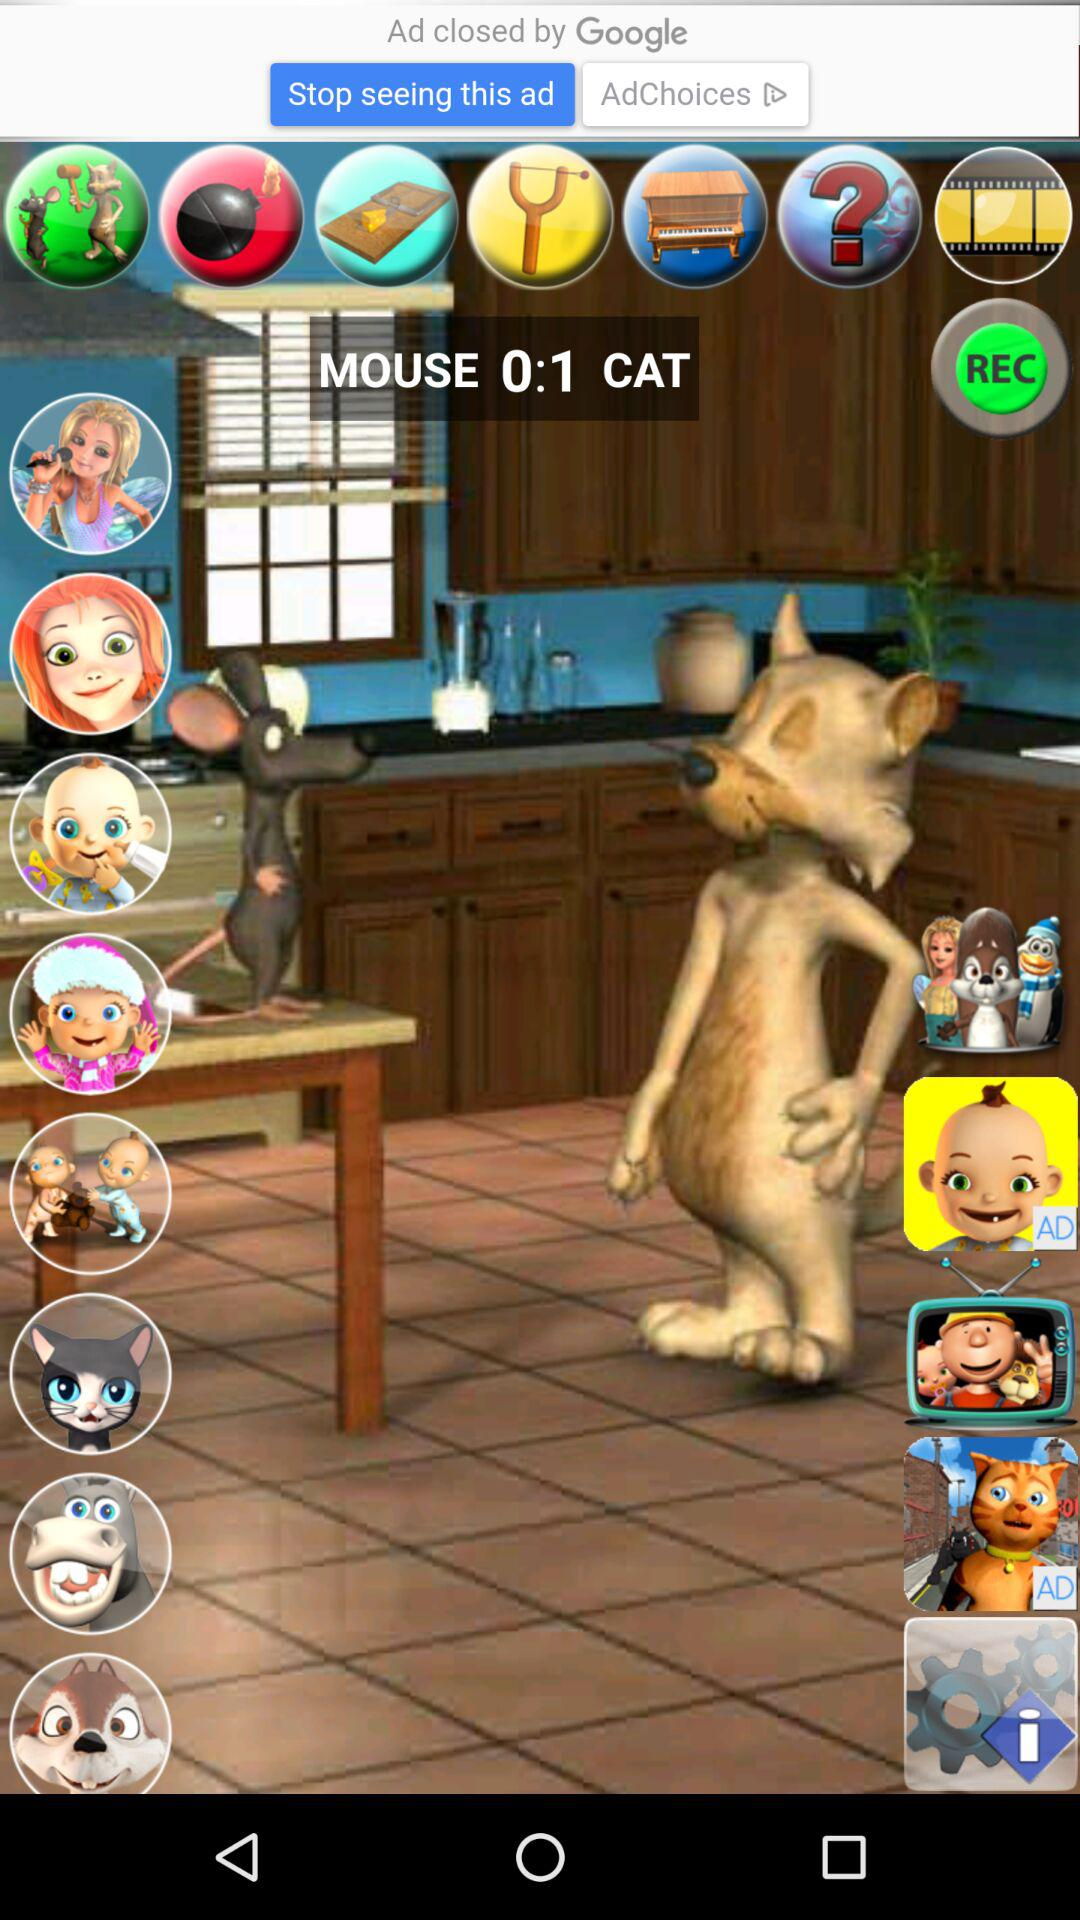What is the score of the mouse and cat? The score is 0:1. 